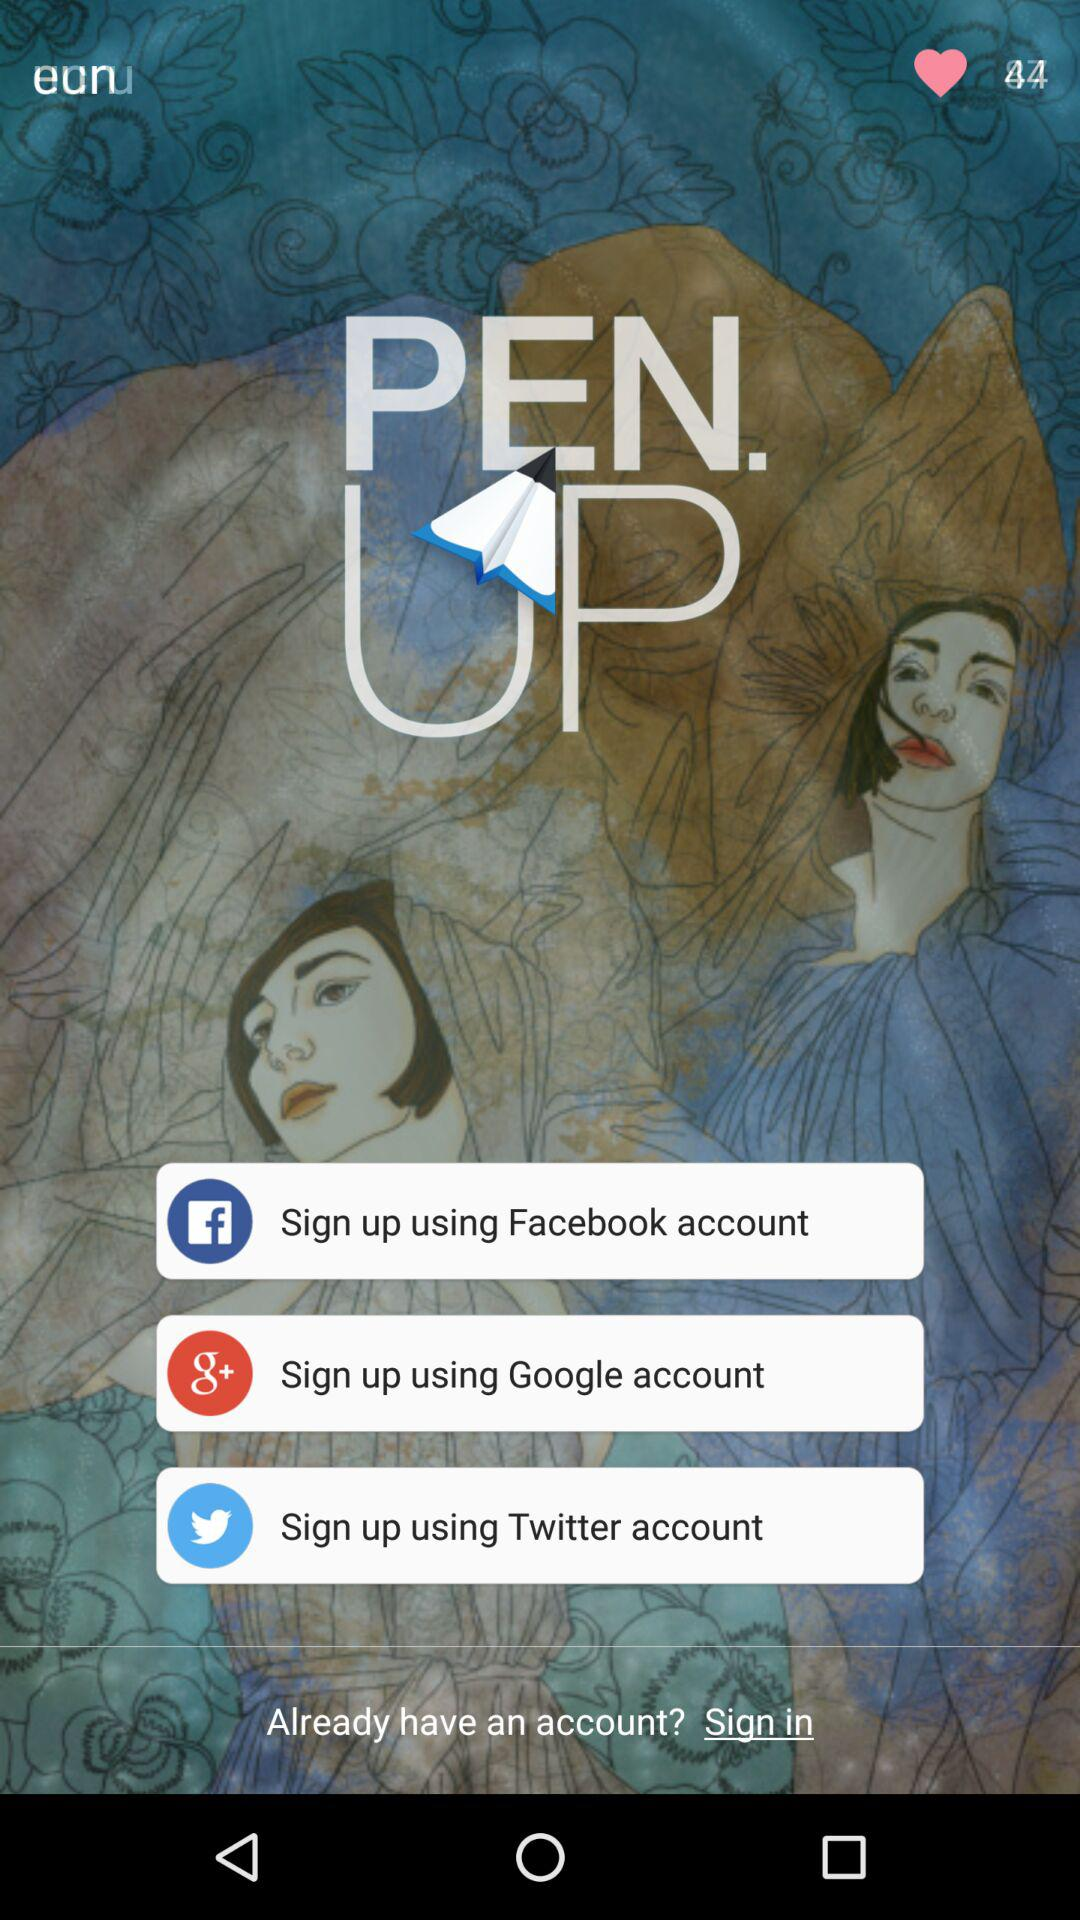What apps can be used for signing up? The apps that can be used for signing up are "Facebook", "Google", and "Twitter". 